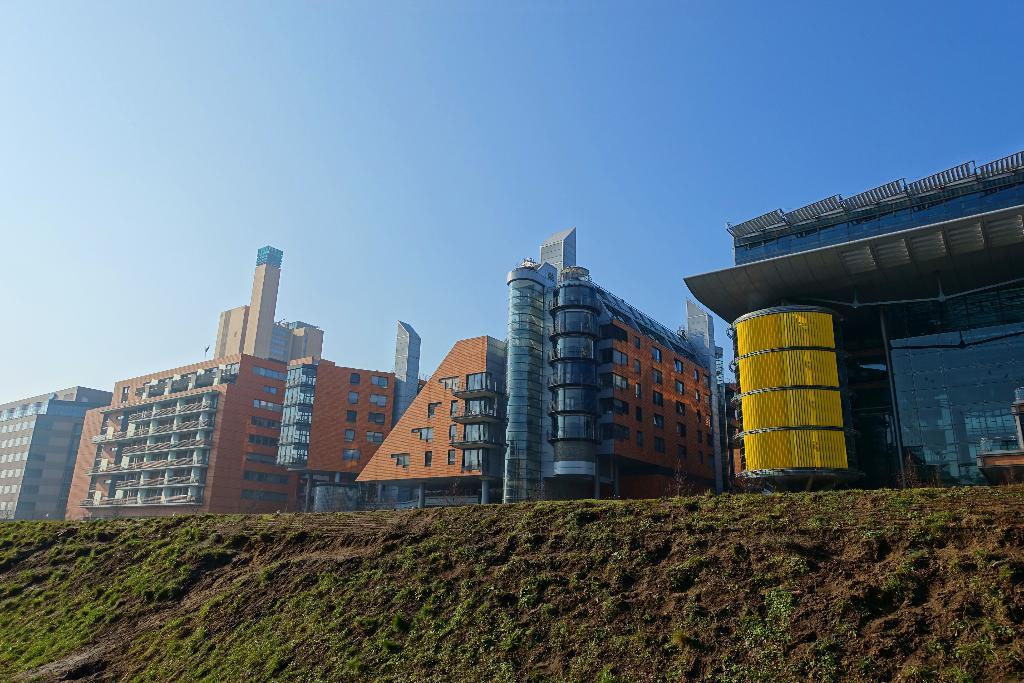What type of vegetation can be seen in the image? There is grass in the image. What type of structures are present in the image? There are buildings in the image. What type of stitch is used to create the view in the image? There is no stitching involved in the image, as it is a photograph or illustration. What thrill can be experienced by looking at the image? The image itself does not convey a thrill; it simply shows grass and buildings. 